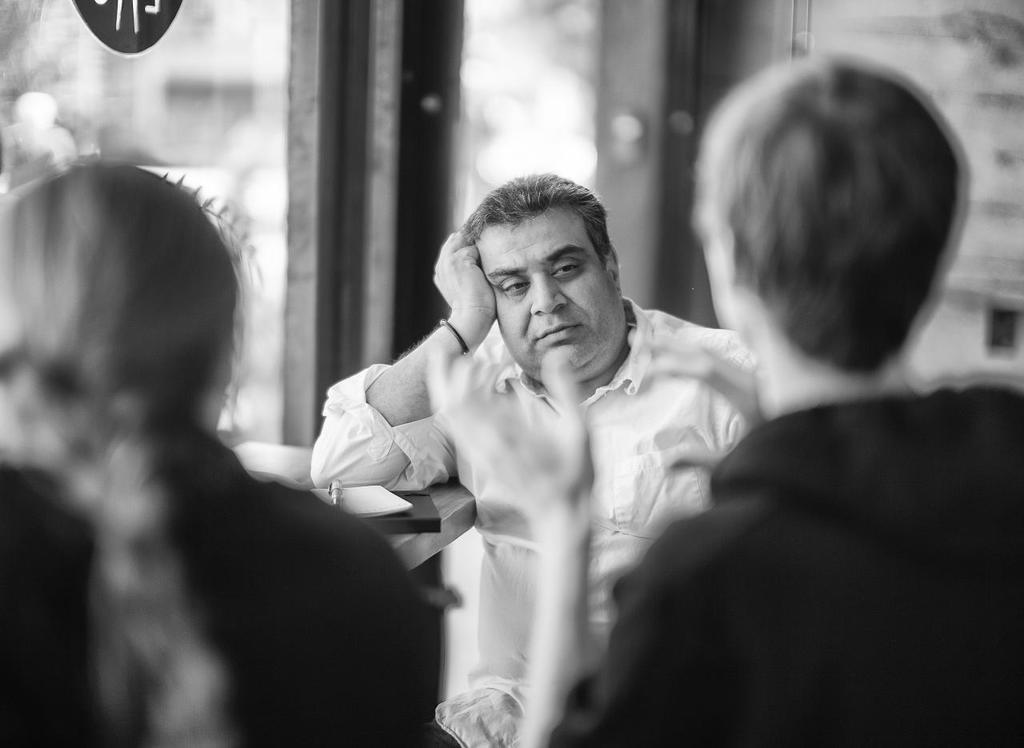What is happening in the foreground of the image? There are people in the foreground of the image. Can you describe the person sitting in front of the table? There is a person sitting in front of a table. What items are on the table? There are books and a pen on the table. What might be visible in the background of the image? It appears that there is a door in the background of the image. What type of cake is being used to write with the pen in the image? There is no cake present in the image, and the pen is not being used to write on a cake. How many pickles are visible on the table in the image? There are no pickles visible on the table in the image. 